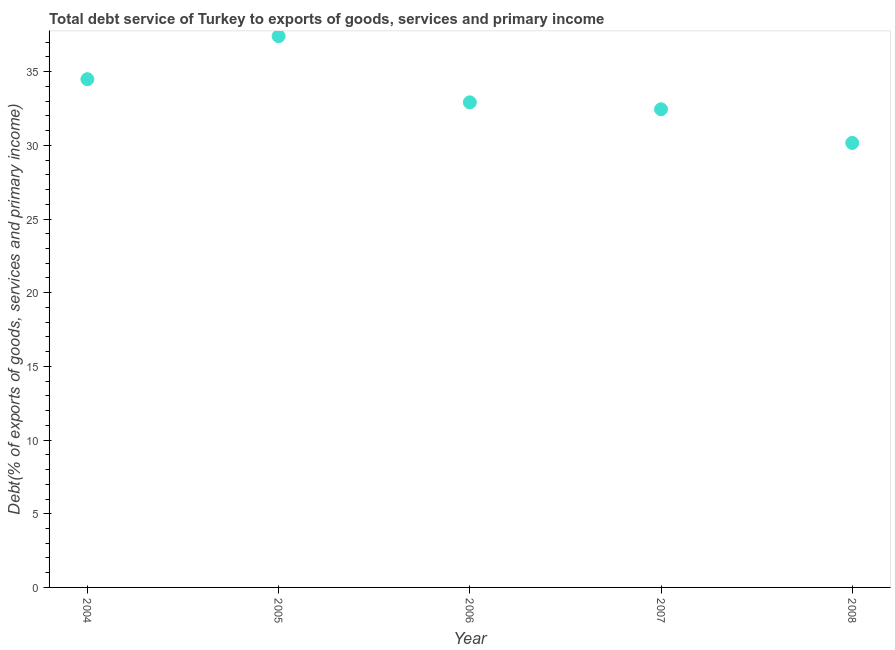What is the total debt service in 2007?
Your response must be concise. 32.45. Across all years, what is the maximum total debt service?
Offer a very short reply. 37.41. Across all years, what is the minimum total debt service?
Your answer should be very brief. 30.17. In which year was the total debt service maximum?
Make the answer very short. 2005. In which year was the total debt service minimum?
Offer a terse response. 2008. What is the sum of the total debt service?
Keep it short and to the point. 167.44. What is the difference between the total debt service in 2007 and 2008?
Give a very brief answer. 2.28. What is the average total debt service per year?
Your answer should be compact. 33.49. What is the median total debt service?
Your answer should be compact. 32.92. Do a majority of the years between 2007 and 2008 (inclusive) have total debt service greater than 24 %?
Provide a succinct answer. Yes. What is the ratio of the total debt service in 2005 to that in 2007?
Make the answer very short. 1.15. Is the total debt service in 2006 less than that in 2007?
Provide a short and direct response. No. What is the difference between the highest and the second highest total debt service?
Give a very brief answer. 2.92. What is the difference between the highest and the lowest total debt service?
Ensure brevity in your answer.  7.25. In how many years, is the total debt service greater than the average total debt service taken over all years?
Provide a succinct answer. 2. Does the total debt service monotonically increase over the years?
Give a very brief answer. No. How many dotlines are there?
Offer a terse response. 1. How many years are there in the graph?
Offer a terse response. 5. Does the graph contain any zero values?
Make the answer very short. No. What is the title of the graph?
Keep it short and to the point. Total debt service of Turkey to exports of goods, services and primary income. What is the label or title of the X-axis?
Give a very brief answer. Year. What is the label or title of the Y-axis?
Keep it short and to the point. Debt(% of exports of goods, services and primary income). What is the Debt(% of exports of goods, services and primary income) in 2004?
Your response must be concise. 34.49. What is the Debt(% of exports of goods, services and primary income) in 2005?
Your answer should be very brief. 37.41. What is the Debt(% of exports of goods, services and primary income) in 2006?
Ensure brevity in your answer.  32.92. What is the Debt(% of exports of goods, services and primary income) in 2007?
Ensure brevity in your answer.  32.45. What is the Debt(% of exports of goods, services and primary income) in 2008?
Make the answer very short. 30.17. What is the difference between the Debt(% of exports of goods, services and primary income) in 2004 and 2005?
Offer a very short reply. -2.92. What is the difference between the Debt(% of exports of goods, services and primary income) in 2004 and 2006?
Offer a terse response. 1.57. What is the difference between the Debt(% of exports of goods, services and primary income) in 2004 and 2007?
Your answer should be very brief. 2.04. What is the difference between the Debt(% of exports of goods, services and primary income) in 2004 and 2008?
Make the answer very short. 4.33. What is the difference between the Debt(% of exports of goods, services and primary income) in 2005 and 2006?
Offer a very short reply. 4.49. What is the difference between the Debt(% of exports of goods, services and primary income) in 2005 and 2007?
Offer a terse response. 4.96. What is the difference between the Debt(% of exports of goods, services and primary income) in 2005 and 2008?
Your answer should be very brief. 7.25. What is the difference between the Debt(% of exports of goods, services and primary income) in 2006 and 2007?
Keep it short and to the point. 0.47. What is the difference between the Debt(% of exports of goods, services and primary income) in 2006 and 2008?
Your answer should be very brief. 2.75. What is the difference between the Debt(% of exports of goods, services and primary income) in 2007 and 2008?
Your response must be concise. 2.28. What is the ratio of the Debt(% of exports of goods, services and primary income) in 2004 to that in 2005?
Provide a succinct answer. 0.92. What is the ratio of the Debt(% of exports of goods, services and primary income) in 2004 to that in 2006?
Your answer should be very brief. 1.05. What is the ratio of the Debt(% of exports of goods, services and primary income) in 2004 to that in 2007?
Keep it short and to the point. 1.06. What is the ratio of the Debt(% of exports of goods, services and primary income) in 2004 to that in 2008?
Your answer should be very brief. 1.14. What is the ratio of the Debt(% of exports of goods, services and primary income) in 2005 to that in 2006?
Your response must be concise. 1.14. What is the ratio of the Debt(% of exports of goods, services and primary income) in 2005 to that in 2007?
Provide a succinct answer. 1.15. What is the ratio of the Debt(% of exports of goods, services and primary income) in 2005 to that in 2008?
Keep it short and to the point. 1.24. What is the ratio of the Debt(% of exports of goods, services and primary income) in 2006 to that in 2008?
Make the answer very short. 1.09. What is the ratio of the Debt(% of exports of goods, services and primary income) in 2007 to that in 2008?
Keep it short and to the point. 1.08. 